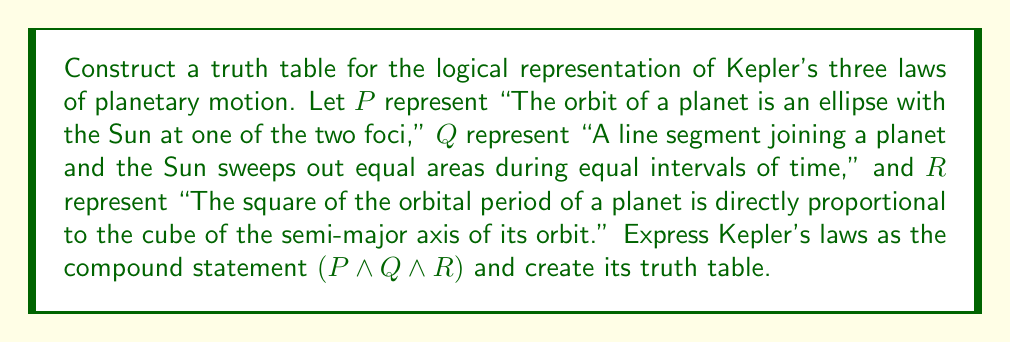Solve this math problem. To construct the truth table for Kepler's laws of planetary motion, we need to follow these steps:

1. Identify the atomic propositions: $P$, $Q$, and $R$.

2. List all possible combinations of truth values for these propositions. With three propositions, we have $2^3 = 8$ rows.

3. Evaluate the truth value of the compound statement $(P \land Q \land R)$ for each combination.

The truth table will have the following structure:

$$
\begin{array}{|c|c|c|c|}
\hline
P & Q & R & (P \land Q \land R) \\
\hline
T & T & T & T \\
T & T & F & F \\
T & F & T & F \\
T & F & F & F \\
F & T & T & F \\
F & T & F & F \\
F & F & T & F \\
F & F & F & F \\
\hline
\end{array}
$$

Explanation of the last column:
- The compound statement $(P \land Q \land R)$ is true only when all three atomic propositions are true.
- If any of the atomic propositions is false, the compound statement is false.

This truth table represents the logical structure of Kepler's laws, showing that all three laws must be true simultaneously for a celestial body to follow Keplerian motion.
Answer: The truth table for Kepler's laws of planetary motion, represented as $(P \land Q \land R)$, is:

$$
\begin{array}{|c|c|c|c|}
\hline
P & Q & R & (P \land Q \land R) \\
\hline
T & T & T & T \\
T & T & F & F \\
T & F & T & F \\
T & F & F & F \\
F & T & T & F \\
F & T & F & F \\
F & F & T & F \\
F & F & F & F \\
\hline
\end{array}
$$ 